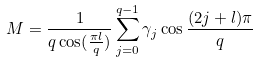Convert formula to latex. <formula><loc_0><loc_0><loc_500><loc_500>M = \frac { 1 } { q \cos ( \frac { \pi l } { q } ) } \sum _ { j = 0 } ^ { q - 1 } \gamma _ { j } \cos \frac { ( 2 j + l ) \pi } { q }</formula> 